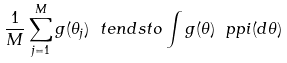<formula> <loc_0><loc_0><loc_500><loc_500>\frac { 1 } { M } \sum _ { j = 1 } ^ { M } g ( \theta _ { j } ) \ t e n d s t o \int g ( \theta ) \ p p i ( d \theta )</formula> 